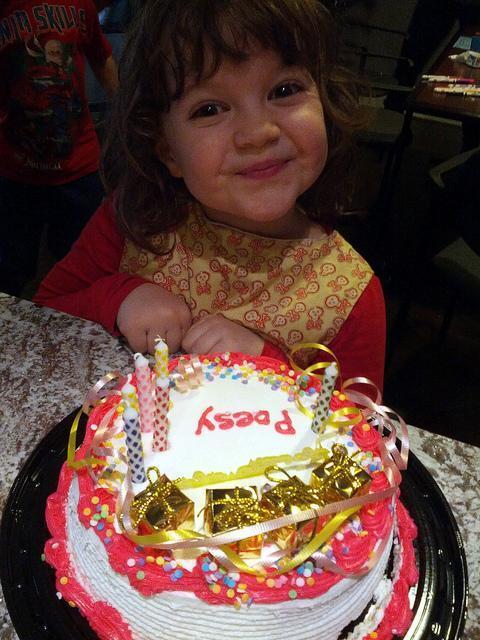How many candles on the cake?
Give a very brief answer. 6. How many people are in the picture?
Give a very brief answer. 2. How many bottles are in the picture?
Give a very brief answer. 0. 